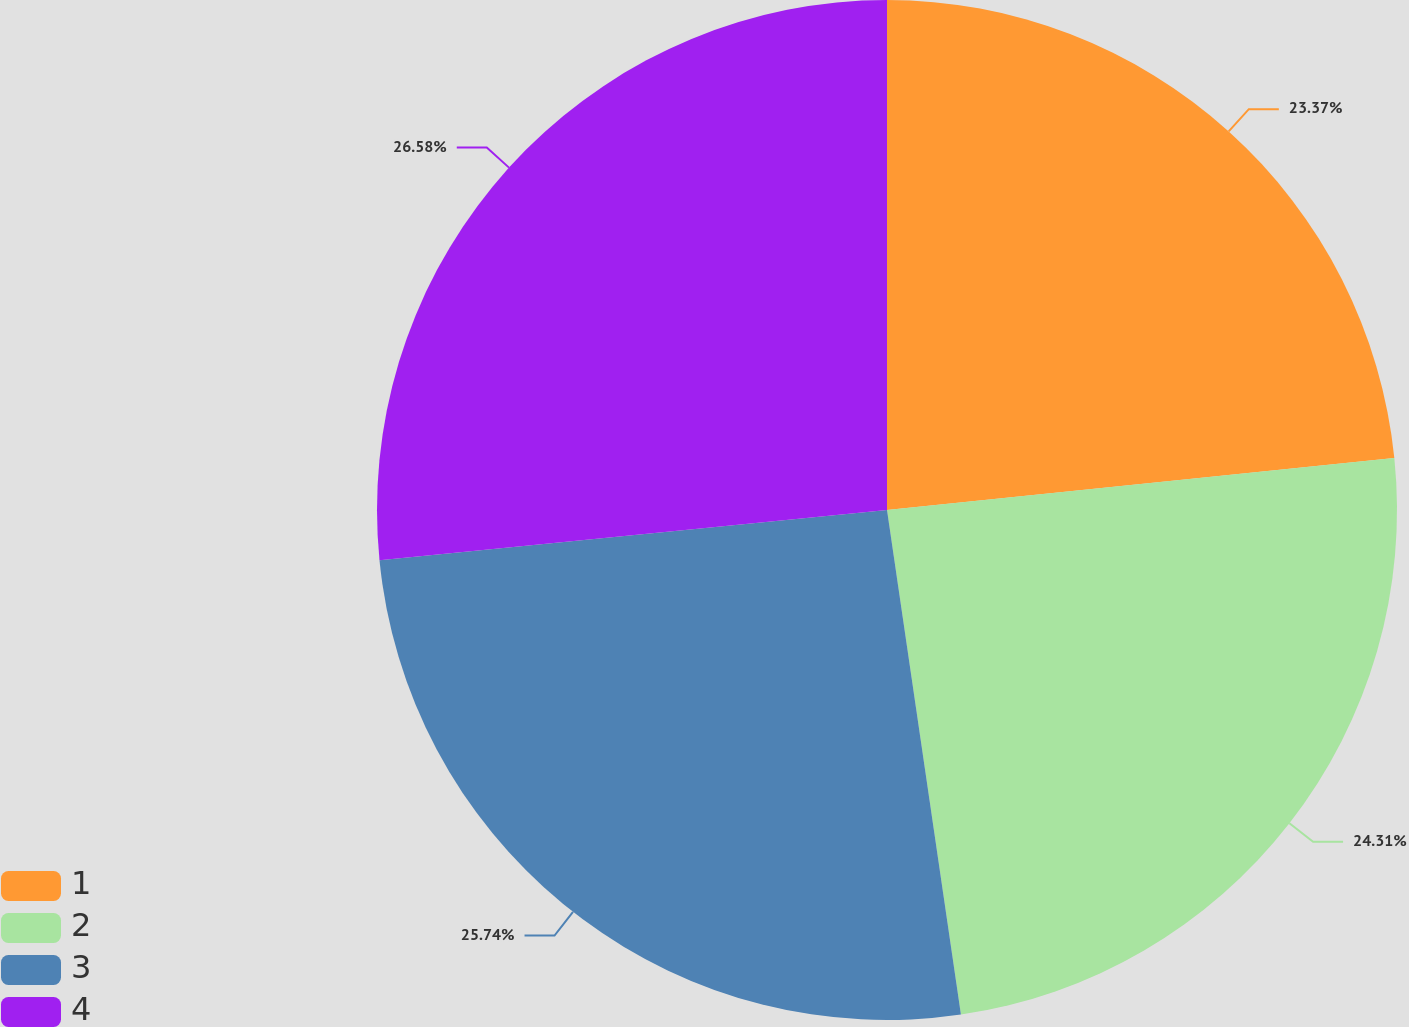Convert chart. <chart><loc_0><loc_0><loc_500><loc_500><pie_chart><fcel>1<fcel>2<fcel>3<fcel>4<nl><fcel>23.37%<fcel>24.31%<fcel>25.74%<fcel>26.57%<nl></chart> 